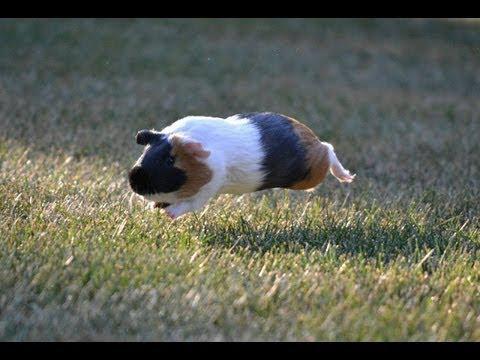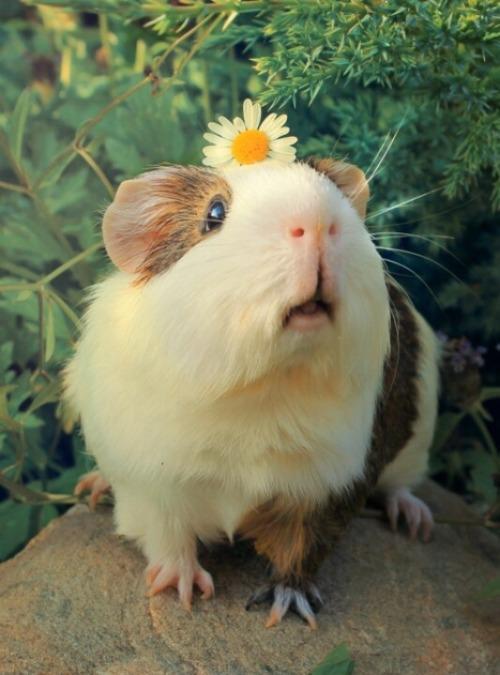The first image is the image on the left, the second image is the image on the right. Assess this claim about the two images: "the image on the right contains a flower". Correct or not? Answer yes or no. Yes. 